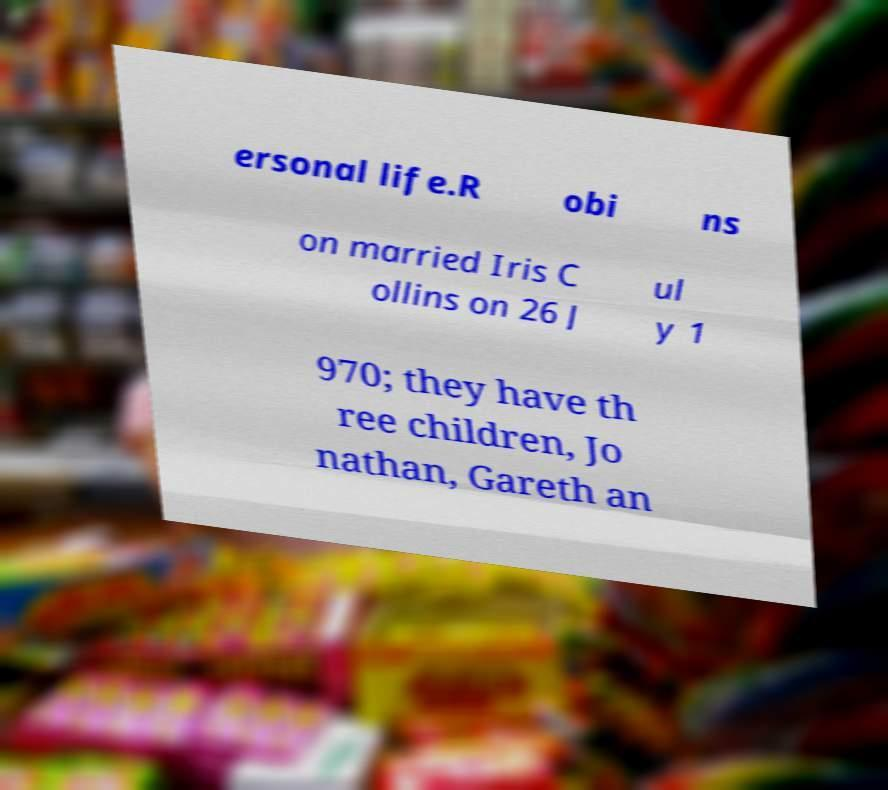I need the written content from this picture converted into text. Can you do that? ersonal life.R obi ns on married Iris C ollins on 26 J ul y 1 970; they have th ree children, Jo nathan, Gareth an 